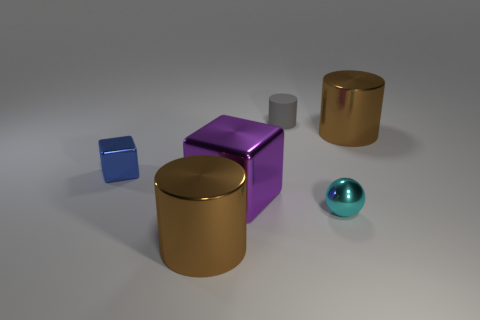What objects can be seen in this image? The image displays a variety of geometric shapes including a purple cube, a small blue cube, a gray cylinder, a golden cylinder, and a reflective teal sphere. 